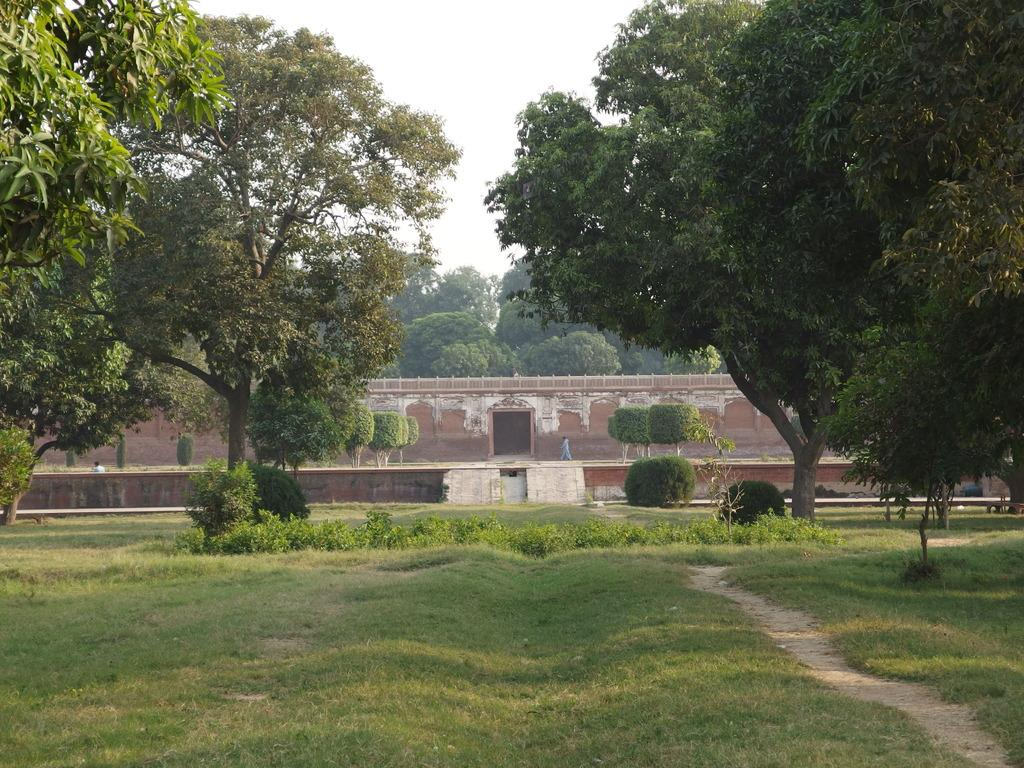What type of vegetation can be seen in the image? There are many trees in the image. What is the ground covered with in the image? There is grass visible in the image. What can be seen at the back side of the image? There is a wall at the back side of the image. What type of jewel is hanging from the tree in the image? There is no jewel hanging from the tree in the image; it only features trees, grass, and a wall. 